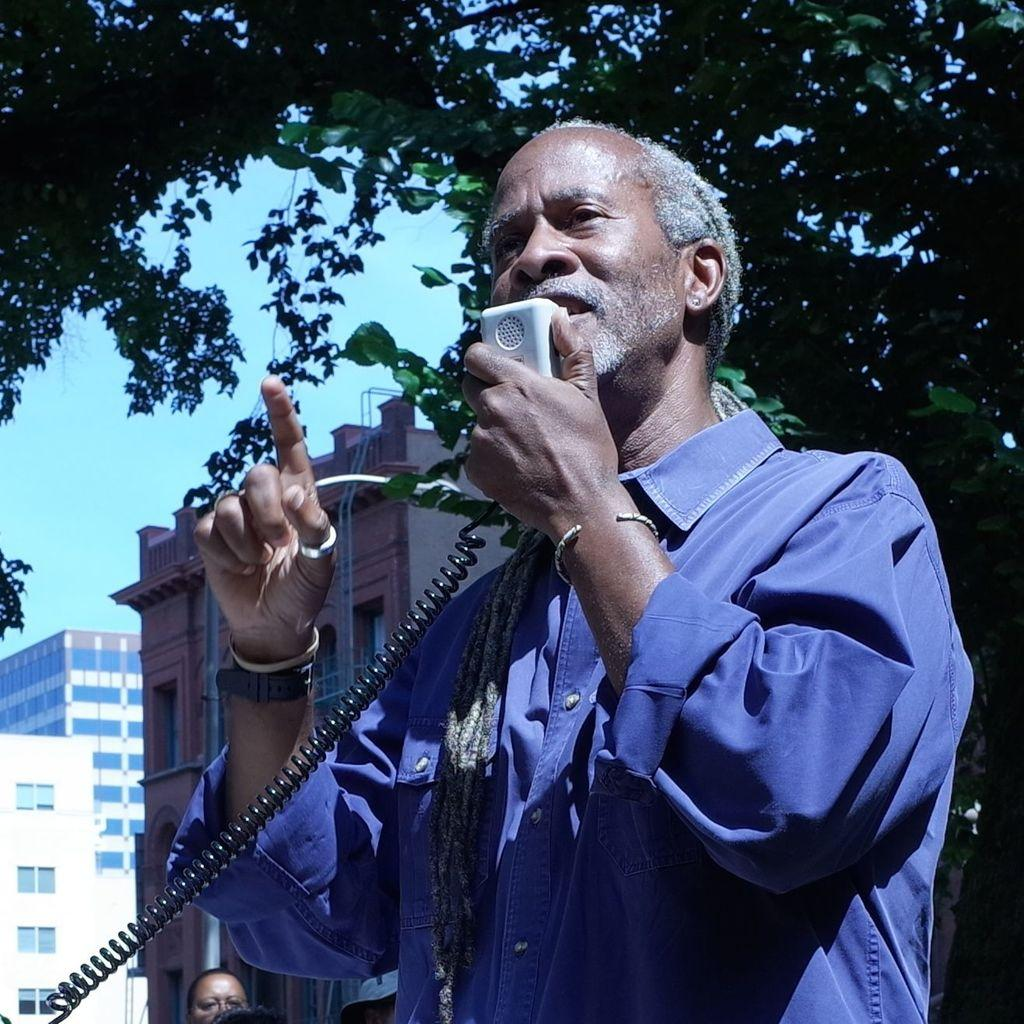What is the man in the image doing? The man is standing and speaking using a handheld walkie-talkie. What can be seen in the background of the image? There are buildings and trees visible in the image. What type of match is the man playing in the image? There is no match or any sporting event present in the image; the man is using a walkie-talkie. What is the taste of the buildings in the image? Buildings do not have a taste, as they are inanimate structures. 